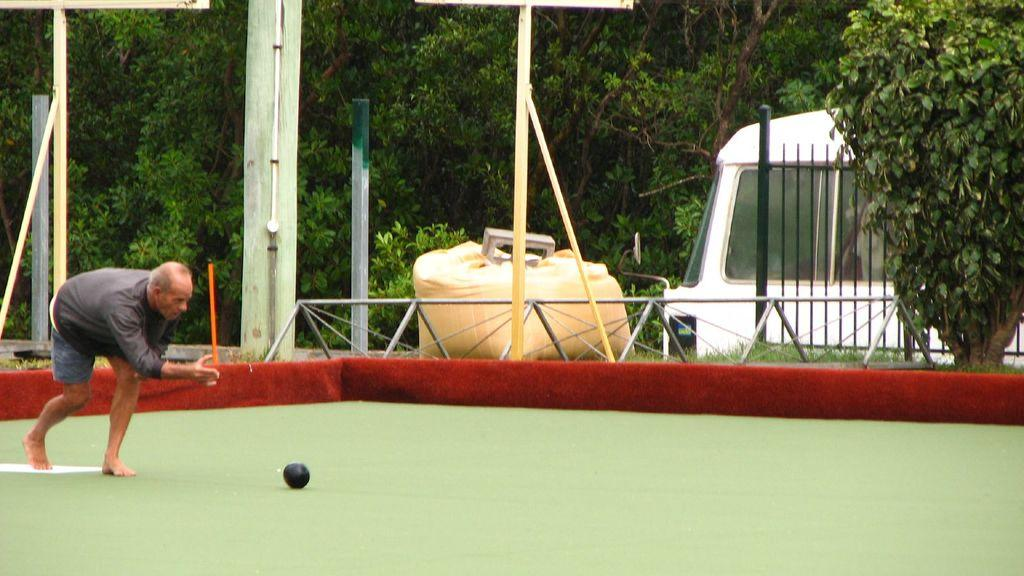What is the main subject of the image? There is a man in the image. What is the man doing in the image? The man is in motion. What object can be seen on the path in the image? There is a ball on the path in the image. What structures are visible in the background of the image? There are poles, a vehicle, a fence, and trees visible in the background of the image. Are there any other unspecified things in the background of the image? Yes, there are other unspecified things in the background of the image. What type of food can be seen on the seashore in the image? There is no seashore or food present in the image. What can the man use to carry his can of paint while walking? The facts provided do not mention a can of paint, so it cannot be determined what the man might use to carry it. 